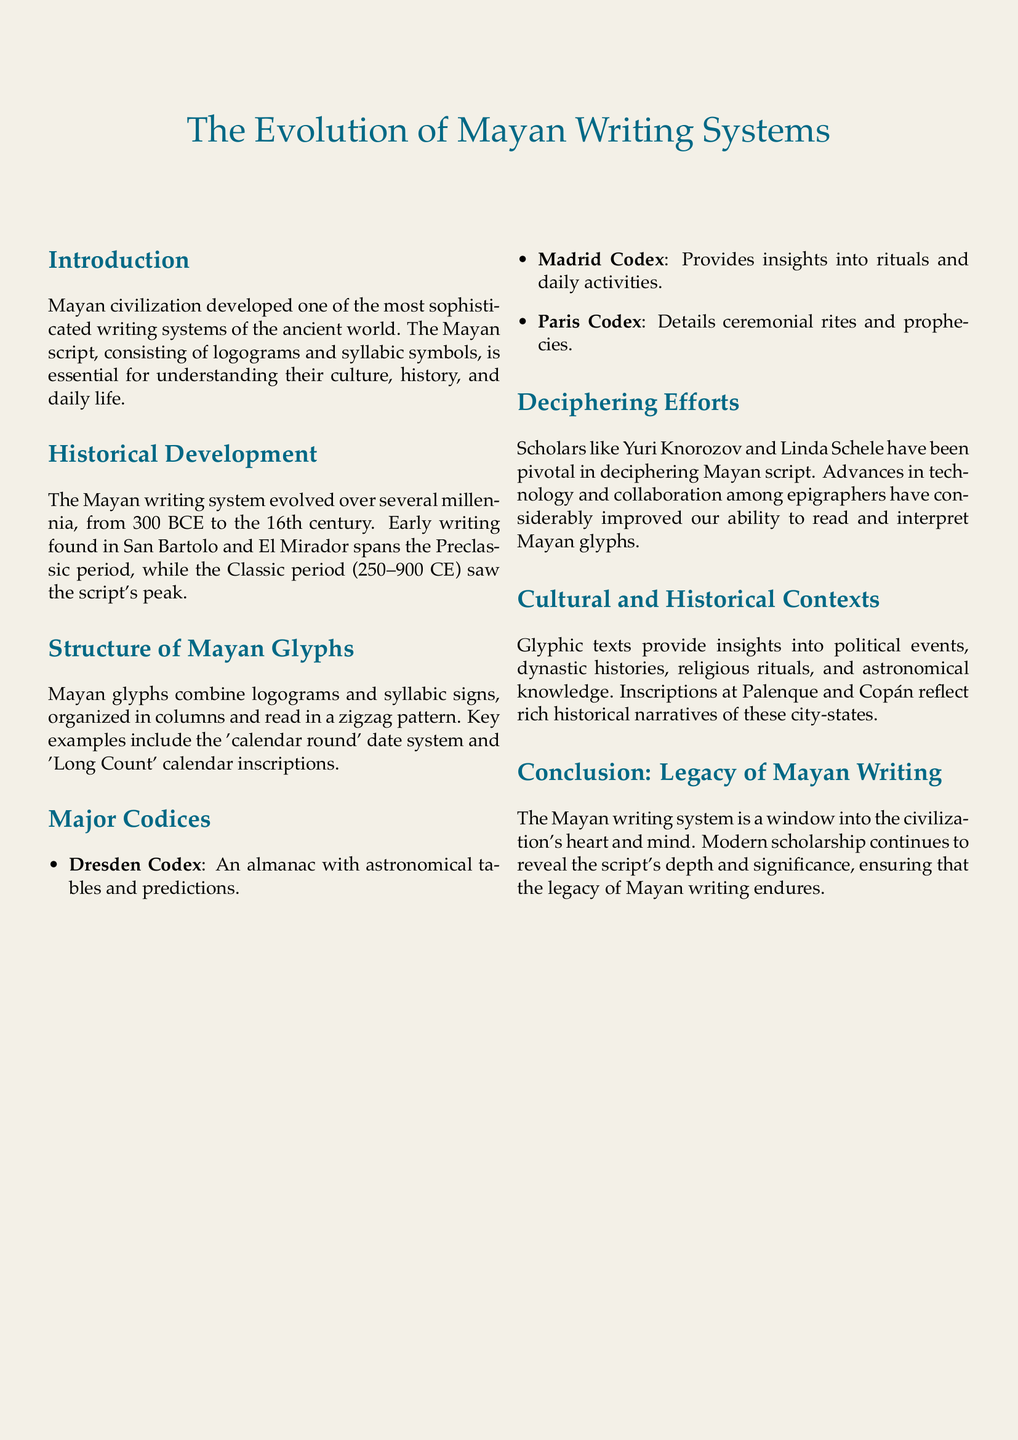What is the time span of the Mayan writing system's evolution? The document states that the Mayan writing system evolved over several millennia, specifically from 300 BCE to the 16th century.
Answer: 300 BCE to 16th century What are the three major codices mentioned? The document lists three major codices as examples of Mayan writing: the Dresden Codex, Madrid Codex, and Paris Codex.
Answer: Dresden Codex, Madrid Codex, Paris Codex Who were the pivotal scholars in deciphering Mayan script? The document mentions Yuri Knorozov and Linda Schele as key figures in the deciphering efforts of Mayan script.
Answer: Yuri Knorozov and Linda Schele What type of symbols does the Mayan script comprise? The document states that the Mayan script consists of logograms and syllabic symbols, highlighting its complexity.
Answer: Logograms and syllabic symbols What is the focus of the Dresden Codex? According to the document, the Dresden Codex is described as an almanac containing astronomical tables and predictions.
Answer: Almanac with astronomical tables What period saw the peak of Mayan writing? The document specifies that the Classic period, which spans from 250 to 900 CE, marks the peak of the Mayan writing script.
Answer: Classic period (250–900 CE) How do Mayan glyphs organize their structure? The document explains that Mayan glyphs are organized in columns and read in a zigzag pattern.
Answer: Columns and zigzag pattern What do glyphic texts provide insights into? The document notes that glyphic texts provide insights into various cultural elements, including political events and religious rituals.
Answer: Political events and religious rituals What does the conclusion of the document emphasize? The conclusion states that the Mayan writing system serves as a window into the civilization's heart and mind, emphasizing its significance.
Answer: Civilization's heart and mind 